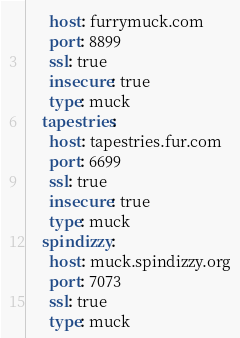<code> <loc_0><loc_0><loc_500><loc_500><_YAML_>      host: furrymuck.com
      port: 8899
      ssl: true
      insecure: true
      type: muck
    tapestries:
      host: tapestries.fur.com
      port: 6699
      ssl: true
      insecure: true
      type: muck
    spindizzy:
      host: muck.spindizzy.org
      port: 7073
      ssl: true
      type: muck
</code> 